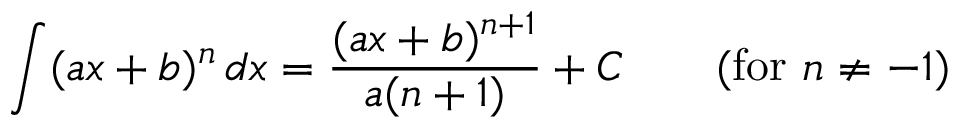Convert formula to latex. <formula><loc_0><loc_0><loc_500><loc_500>\int ( a x + b ) ^ { n } \, d x = { \frac { ( a x + b ) ^ { n + 1 } } { a ( n + 1 ) } } + C \quad { ( f o r } n \neq - 1 { ) }</formula> 